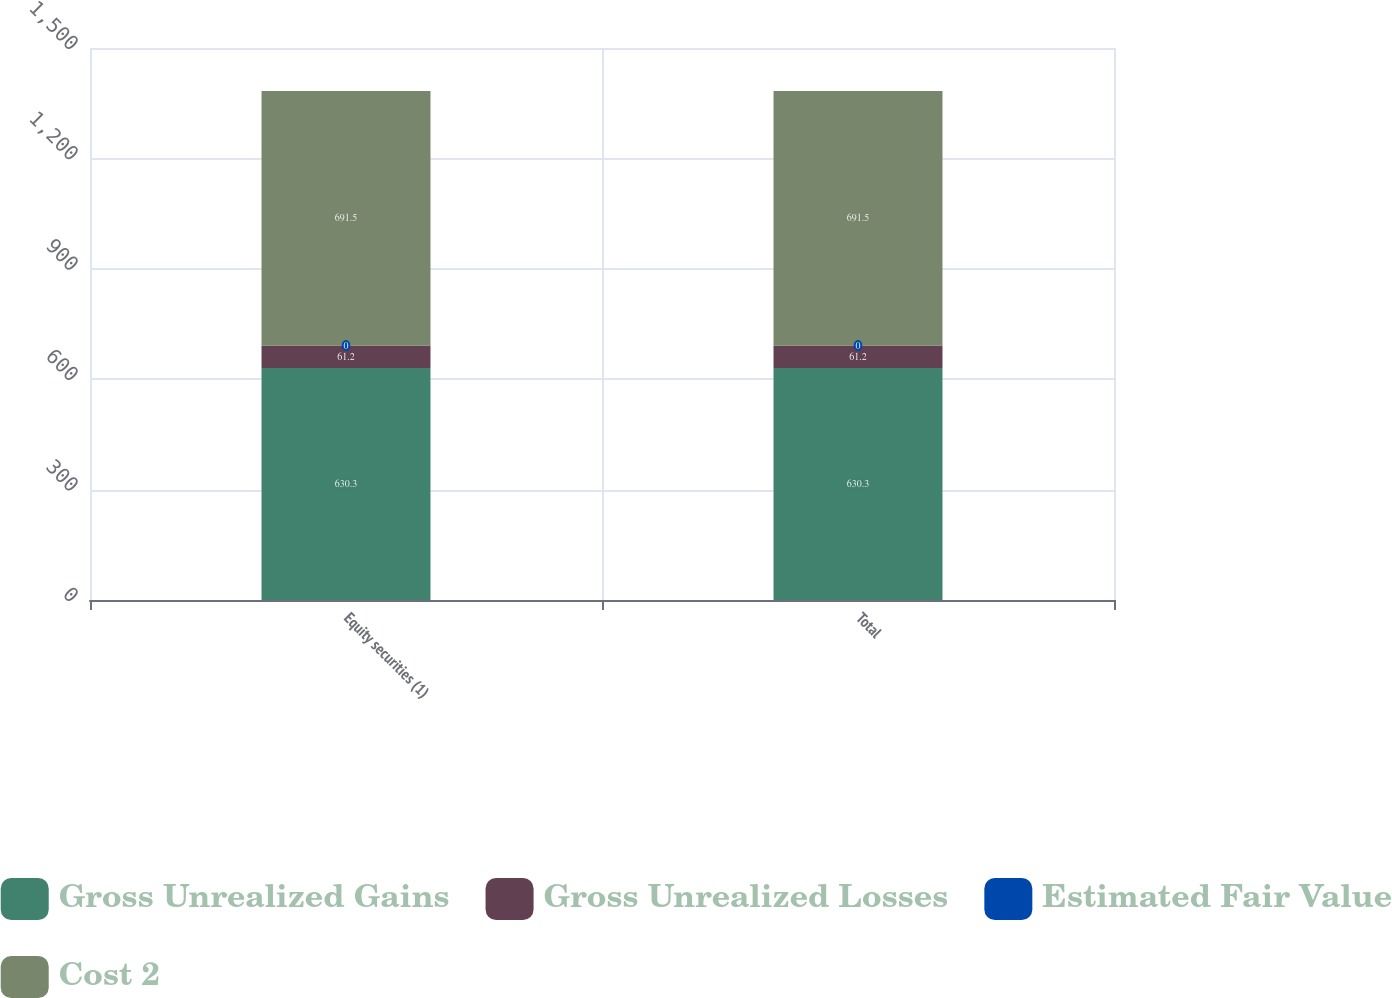<chart> <loc_0><loc_0><loc_500><loc_500><stacked_bar_chart><ecel><fcel>Equity securities (1)<fcel>Total<nl><fcel>Gross Unrealized Gains<fcel>630.3<fcel>630.3<nl><fcel>Gross Unrealized Losses<fcel>61.2<fcel>61.2<nl><fcel>Estimated Fair Value<fcel>0<fcel>0<nl><fcel>Cost 2<fcel>691.5<fcel>691.5<nl></chart> 